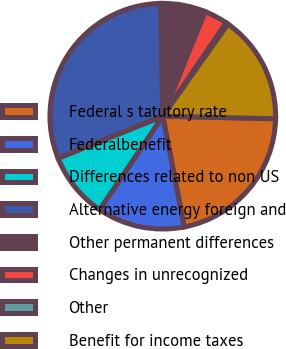Convert chart to OTSL. <chart><loc_0><loc_0><loc_500><loc_500><pie_chart><fcel>Federal s tatutory rate<fcel>Federalbenefit<fcel>Differences related to non US<fcel>Alternative energy foreign and<fcel>Other permanent differences<fcel>Changes in unrecognized<fcel>Other<fcel>Benefit for income taxes<nl><fcel>21.6%<fcel>12.51%<fcel>9.46%<fcel>30.8%<fcel>6.41%<fcel>3.36%<fcel>0.31%<fcel>15.56%<nl></chart> 